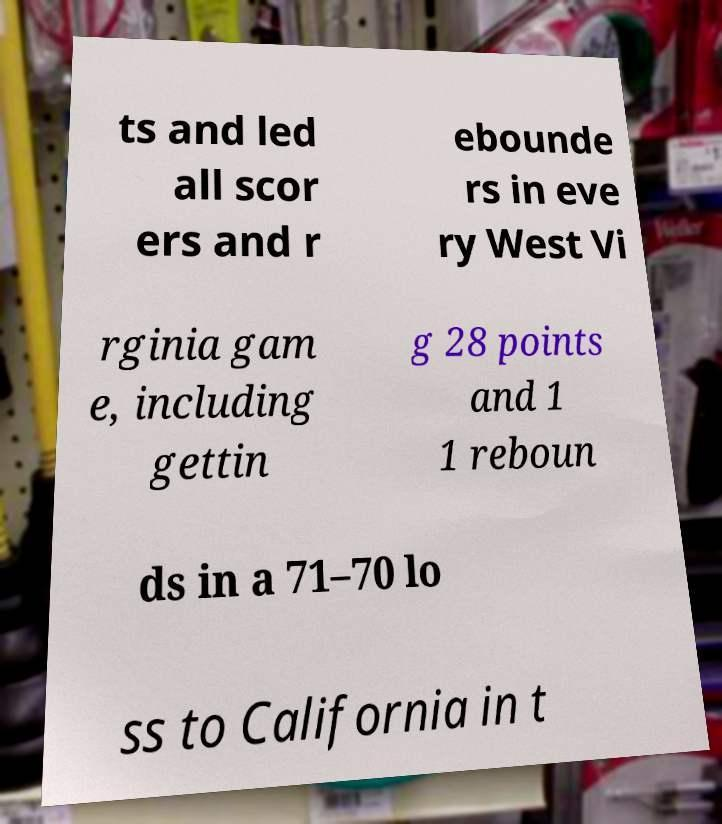Can you accurately transcribe the text from the provided image for me? ts and led all scor ers and r ebounde rs in eve ry West Vi rginia gam e, including gettin g 28 points and 1 1 reboun ds in a 71–70 lo ss to California in t 